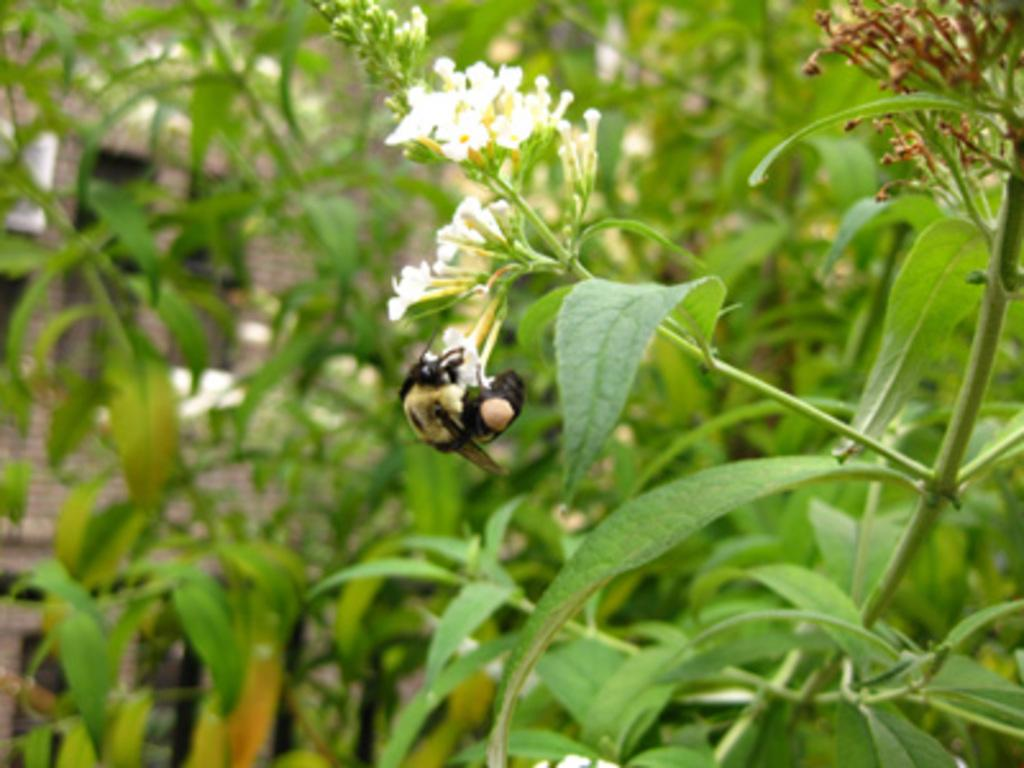What is on the flowers of the plant in the image? There is a bee on the flowers of a plant in the image. What else can be seen in the image besides the bee and the plant? There are other plants visible in the background of the image. What angle does the animal approach the bee in the image? There is no animal present in the image, so it is not possible to determine the angle at which an animal might approach the bee. 